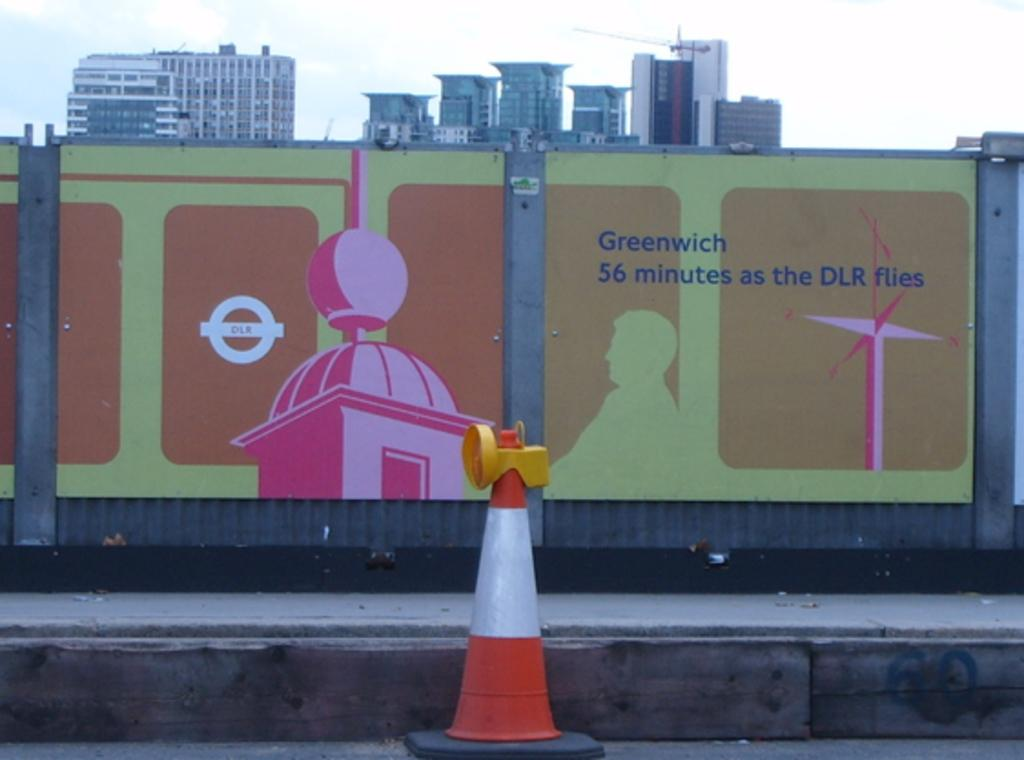<image>
Present a compact description of the photo's key features. A painted fence with information about Greenwich sits in front of an orange and white traffic cone. 